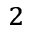Convert formula to latex. <formula><loc_0><loc_0><loc_500><loc_500>_ { 2 }</formula> 